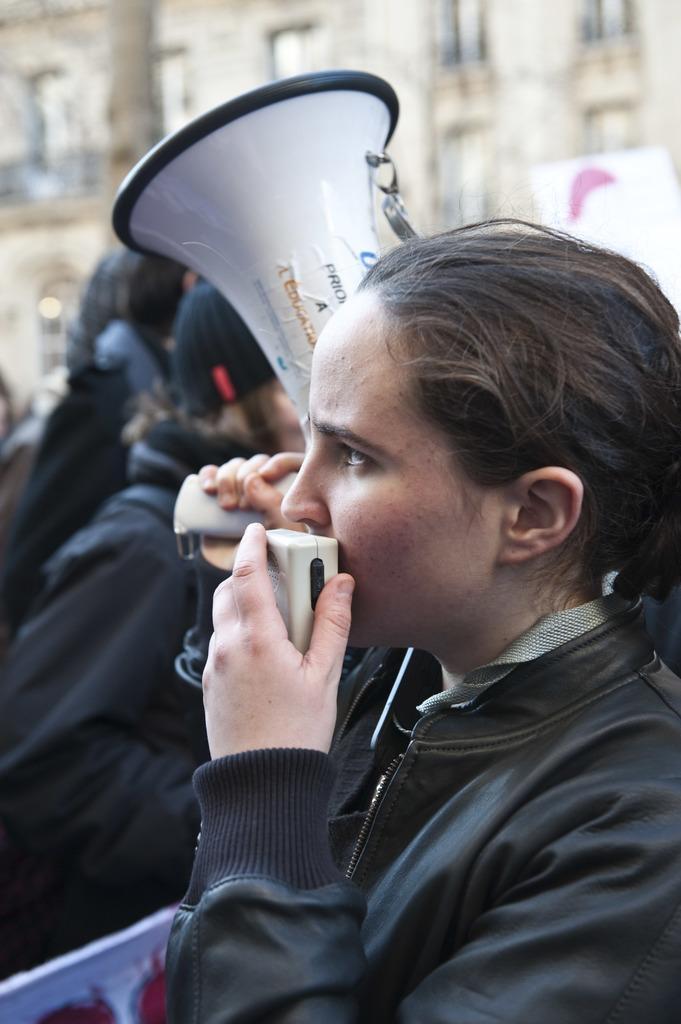In one or two sentences, can you explain what this image depicts? In this image I can see a woman in the front. She is holding an object. There is a megaphone and other people are present. There is a building at the back. 